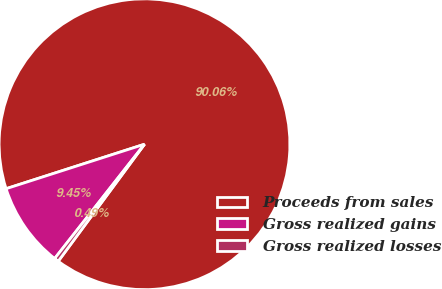Convert chart to OTSL. <chart><loc_0><loc_0><loc_500><loc_500><pie_chart><fcel>Proceeds from sales<fcel>Gross realized gains<fcel>Gross realized losses<nl><fcel>90.06%<fcel>9.45%<fcel>0.49%<nl></chart> 